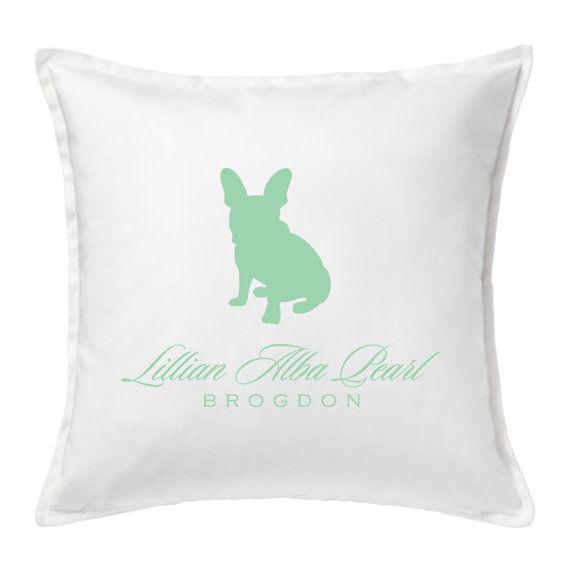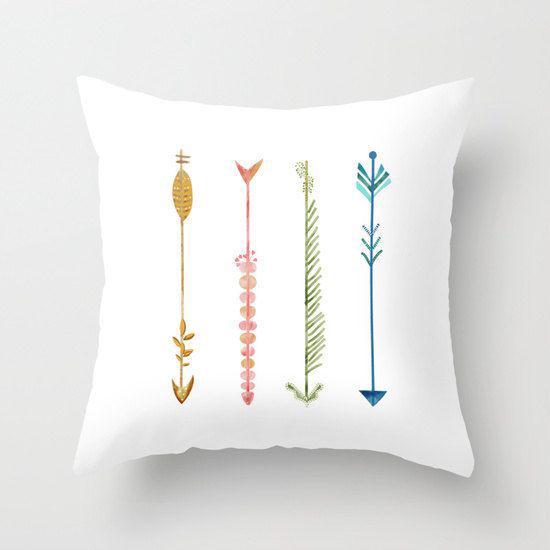The first image is the image on the left, the second image is the image on the right. Analyze the images presented: Is the assertion "The pillows in the image on the left have words on them." valid? Answer yes or no. Yes. The first image is the image on the left, the second image is the image on the right. Assess this claim about the two images: "The lefthand image shows a pillow decorated with at least one symmetrical sky-blue shape that resembles a snowflake.". Correct or not? Answer yes or no. No. 